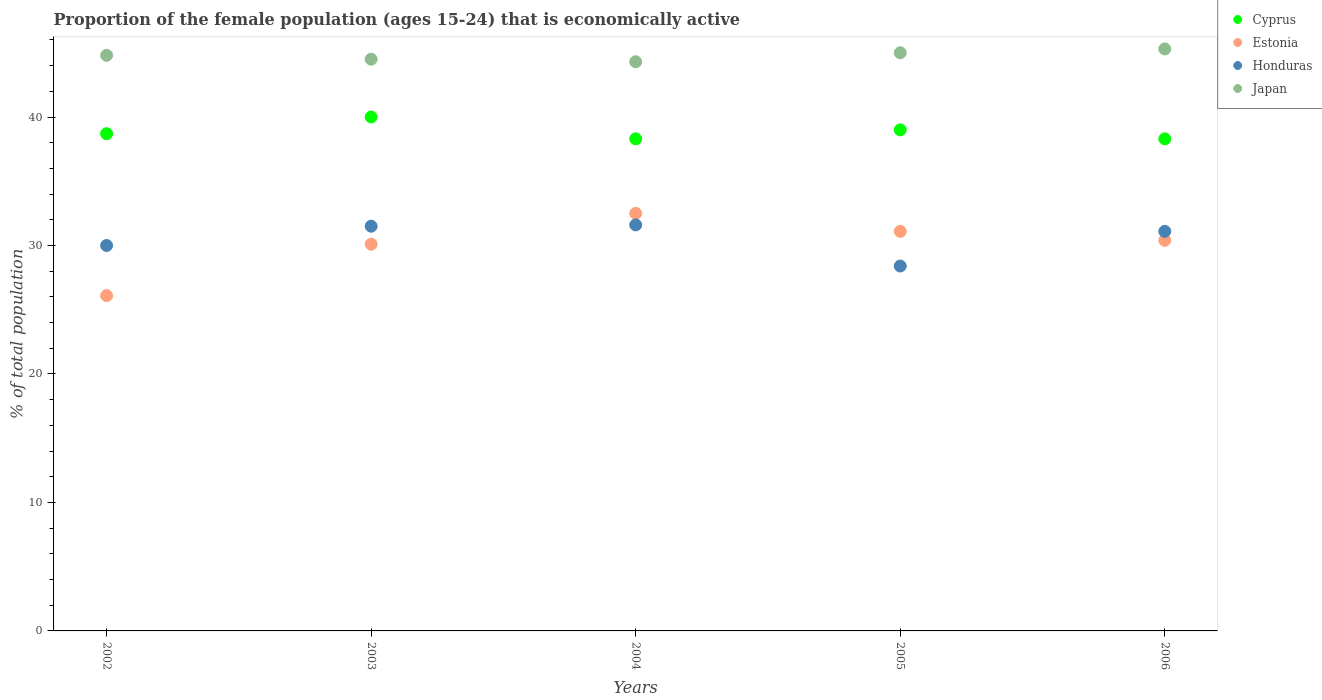How many different coloured dotlines are there?
Your answer should be compact. 4. What is the proportion of the female population that is economically active in Japan in 2004?
Offer a very short reply. 44.3. Across all years, what is the maximum proportion of the female population that is economically active in Cyprus?
Give a very brief answer. 40. Across all years, what is the minimum proportion of the female population that is economically active in Japan?
Provide a succinct answer. 44.3. What is the total proportion of the female population that is economically active in Japan in the graph?
Provide a succinct answer. 223.9. What is the difference between the proportion of the female population that is economically active in Honduras in 2003 and that in 2006?
Your answer should be very brief. 0.4. What is the difference between the proportion of the female population that is economically active in Cyprus in 2006 and the proportion of the female population that is economically active in Estonia in 2005?
Provide a short and direct response. 7.2. What is the average proportion of the female population that is economically active in Japan per year?
Give a very brief answer. 44.78. In the year 2005, what is the difference between the proportion of the female population that is economically active in Japan and proportion of the female population that is economically active in Cyprus?
Your answer should be very brief. 6. In how many years, is the proportion of the female population that is economically active in Honduras greater than 36 %?
Make the answer very short. 0. What is the ratio of the proportion of the female population that is economically active in Cyprus in 2002 to that in 2004?
Ensure brevity in your answer.  1.01. Is the difference between the proportion of the female population that is economically active in Japan in 2003 and 2006 greater than the difference between the proportion of the female population that is economically active in Cyprus in 2003 and 2006?
Provide a succinct answer. No. What is the difference between the highest and the second highest proportion of the female population that is economically active in Honduras?
Your answer should be compact. 0.1. What is the difference between the highest and the lowest proportion of the female population that is economically active in Cyprus?
Provide a succinct answer. 1.7. In how many years, is the proportion of the female population that is economically active in Japan greater than the average proportion of the female population that is economically active in Japan taken over all years?
Give a very brief answer. 3. How many dotlines are there?
Offer a terse response. 4. Are the values on the major ticks of Y-axis written in scientific E-notation?
Keep it short and to the point. No. Does the graph contain grids?
Offer a very short reply. No. What is the title of the graph?
Ensure brevity in your answer.  Proportion of the female population (ages 15-24) that is economically active. What is the label or title of the X-axis?
Your response must be concise. Years. What is the label or title of the Y-axis?
Provide a short and direct response. % of total population. What is the % of total population of Cyprus in 2002?
Ensure brevity in your answer.  38.7. What is the % of total population in Estonia in 2002?
Ensure brevity in your answer.  26.1. What is the % of total population of Japan in 2002?
Your answer should be very brief. 44.8. What is the % of total population in Estonia in 2003?
Provide a short and direct response. 30.1. What is the % of total population of Honduras in 2003?
Provide a succinct answer. 31.5. What is the % of total population of Japan in 2003?
Provide a succinct answer. 44.5. What is the % of total population in Cyprus in 2004?
Keep it short and to the point. 38.3. What is the % of total population of Estonia in 2004?
Your response must be concise. 32.5. What is the % of total population of Honduras in 2004?
Keep it short and to the point. 31.6. What is the % of total population in Japan in 2004?
Make the answer very short. 44.3. What is the % of total population in Cyprus in 2005?
Provide a succinct answer. 39. What is the % of total population in Estonia in 2005?
Your answer should be compact. 31.1. What is the % of total population in Honduras in 2005?
Provide a succinct answer. 28.4. What is the % of total population of Cyprus in 2006?
Ensure brevity in your answer.  38.3. What is the % of total population of Estonia in 2006?
Offer a terse response. 30.4. What is the % of total population in Honduras in 2006?
Your answer should be compact. 31.1. What is the % of total population of Japan in 2006?
Your answer should be compact. 45.3. Across all years, what is the maximum % of total population in Cyprus?
Offer a terse response. 40. Across all years, what is the maximum % of total population in Estonia?
Your answer should be very brief. 32.5. Across all years, what is the maximum % of total population in Honduras?
Your answer should be compact. 31.6. Across all years, what is the maximum % of total population in Japan?
Your answer should be very brief. 45.3. Across all years, what is the minimum % of total population in Cyprus?
Offer a very short reply. 38.3. Across all years, what is the minimum % of total population of Estonia?
Provide a succinct answer. 26.1. Across all years, what is the minimum % of total population of Honduras?
Provide a short and direct response. 28.4. Across all years, what is the minimum % of total population in Japan?
Ensure brevity in your answer.  44.3. What is the total % of total population in Cyprus in the graph?
Ensure brevity in your answer.  194.3. What is the total % of total population of Estonia in the graph?
Keep it short and to the point. 150.2. What is the total % of total population in Honduras in the graph?
Ensure brevity in your answer.  152.6. What is the total % of total population of Japan in the graph?
Give a very brief answer. 223.9. What is the difference between the % of total population in Cyprus in 2002 and that in 2003?
Offer a terse response. -1.3. What is the difference between the % of total population of Japan in 2002 and that in 2003?
Make the answer very short. 0.3. What is the difference between the % of total population in Cyprus in 2002 and that in 2004?
Ensure brevity in your answer.  0.4. What is the difference between the % of total population of Estonia in 2002 and that in 2004?
Your answer should be compact. -6.4. What is the difference between the % of total population of Japan in 2002 and that in 2004?
Your response must be concise. 0.5. What is the difference between the % of total population of Estonia in 2002 and that in 2005?
Give a very brief answer. -5. What is the difference between the % of total population in Japan in 2002 and that in 2005?
Your answer should be compact. -0.2. What is the difference between the % of total population in Cyprus in 2002 and that in 2006?
Offer a very short reply. 0.4. What is the difference between the % of total population of Cyprus in 2003 and that in 2004?
Provide a short and direct response. 1.7. What is the difference between the % of total population in Honduras in 2003 and that in 2004?
Keep it short and to the point. -0.1. What is the difference between the % of total population of Japan in 2003 and that in 2004?
Your answer should be compact. 0.2. What is the difference between the % of total population in Japan in 2003 and that in 2005?
Ensure brevity in your answer.  -0.5. What is the difference between the % of total population in Cyprus in 2003 and that in 2006?
Offer a terse response. 1.7. What is the difference between the % of total population in Estonia in 2003 and that in 2006?
Provide a short and direct response. -0.3. What is the difference between the % of total population of Estonia in 2004 and that in 2005?
Offer a terse response. 1.4. What is the difference between the % of total population of Japan in 2004 and that in 2005?
Keep it short and to the point. -0.7. What is the difference between the % of total population in Cyprus in 2004 and that in 2006?
Offer a very short reply. 0. What is the difference between the % of total population in Estonia in 2004 and that in 2006?
Offer a terse response. 2.1. What is the difference between the % of total population of Honduras in 2004 and that in 2006?
Your response must be concise. 0.5. What is the difference between the % of total population in Cyprus in 2005 and that in 2006?
Your answer should be very brief. 0.7. What is the difference between the % of total population of Estonia in 2005 and that in 2006?
Ensure brevity in your answer.  0.7. What is the difference between the % of total population of Honduras in 2005 and that in 2006?
Make the answer very short. -2.7. What is the difference between the % of total population of Japan in 2005 and that in 2006?
Make the answer very short. -0.3. What is the difference between the % of total population of Estonia in 2002 and the % of total population of Honduras in 2003?
Your answer should be very brief. -5.4. What is the difference between the % of total population of Estonia in 2002 and the % of total population of Japan in 2003?
Offer a terse response. -18.4. What is the difference between the % of total population of Honduras in 2002 and the % of total population of Japan in 2003?
Your answer should be compact. -14.5. What is the difference between the % of total population in Cyprus in 2002 and the % of total population in Honduras in 2004?
Give a very brief answer. 7.1. What is the difference between the % of total population in Cyprus in 2002 and the % of total population in Japan in 2004?
Provide a short and direct response. -5.6. What is the difference between the % of total population of Estonia in 2002 and the % of total population of Honduras in 2004?
Your answer should be compact. -5.5. What is the difference between the % of total population in Estonia in 2002 and the % of total population in Japan in 2004?
Provide a succinct answer. -18.2. What is the difference between the % of total population of Honduras in 2002 and the % of total population of Japan in 2004?
Provide a short and direct response. -14.3. What is the difference between the % of total population in Cyprus in 2002 and the % of total population in Estonia in 2005?
Provide a short and direct response. 7.6. What is the difference between the % of total population in Estonia in 2002 and the % of total population in Japan in 2005?
Offer a very short reply. -18.9. What is the difference between the % of total population in Honduras in 2002 and the % of total population in Japan in 2005?
Give a very brief answer. -15. What is the difference between the % of total population in Cyprus in 2002 and the % of total population in Estonia in 2006?
Offer a terse response. 8.3. What is the difference between the % of total population in Cyprus in 2002 and the % of total population in Honduras in 2006?
Ensure brevity in your answer.  7.6. What is the difference between the % of total population in Cyprus in 2002 and the % of total population in Japan in 2006?
Keep it short and to the point. -6.6. What is the difference between the % of total population in Estonia in 2002 and the % of total population in Japan in 2006?
Provide a succinct answer. -19.2. What is the difference between the % of total population of Honduras in 2002 and the % of total population of Japan in 2006?
Ensure brevity in your answer.  -15.3. What is the difference between the % of total population in Cyprus in 2003 and the % of total population in Estonia in 2004?
Provide a short and direct response. 7.5. What is the difference between the % of total population of Cyprus in 2003 and the % of total population of Honduras in 2004?
Keep it short and to the point. 8.4. What is the difference between the % of total population of Estonia in 2003 and the % of total population of Honduras in 2004?
Provide a short and direct response. -1.5. What is the difference between the % of total population in Estonia in 2003 and the % of total population in Japan in 2004?
Offer a terse response. -14.2. What is the difference between the % of total population in Honduras in 2003 and the % of total population in Japan in 2004?
Provide a short and direct response. -12.8. What is the difference between the % of total population of Cyprus in 2003 and the % of total population of Estonia in 2005?
Make the answer very short. 8.9. What is the difference between the % of total population of Cyprus in 2003 and the % of total population of Japan in 2005?
Keep it short and to the point. -5. What is the difference between the % of total population of Estonia in 2003 and the % of total population of Honduras in 2005?
Offer a terse response. 1.7. What is the difference between the % of total population in Estonia in 2003 and the % of total population in Japan in 2005?
Offer a very short reply. -14.9. What is the difference between the % of total population in Cyprus in 2003 and the % of total population in Honduras in 2006?
Your answer should be compact. 8.9. What is the difference between the % of total population of Estonia in 2003 and the % of total population of Honduras in 2006?
Keep it short and to the point. -1. What is the difference between the % of total population in Estonia in 2003 and the % of total population in Japan in 2006?
Provide a succinct answer. -15.2. What is the difference between the % of total population in Honduras in 2003 and the % of total population in Japan in 2006?
Your answer should be compact. -13.8. What is the difference between the % of total population in Cyprus in 2004 and the % of total population in Estonia in 2005?
Your response must be concise. 7.2. What is the difference between the % of total population of Estonia in 2004 and the % of total population of Japan in 2005?
Your response must be concise. -12.5. What is the difference between the % of total population of Cyprus in 2004 and the % of total population of Honduras in 2006?
Offer a very short reply. 7.2. What is the difference between the % of total population in Estonia in 2004 and the % of total population in Honduras in 2006?
Your response must be concise. 1.4. What is the difference between the % of total population in Estonia in 2004 and the % of total population in Japan in 2006?
Keep it short and to the point. -12.8. What is the difference between the % of total population of Honduras in 2004 and the % of total population of Japan in 2006?
Your answer should be compact. -13.7. What is the difference between the % of total population in Honduras in 2005 and the % of total population in Japan in 2006?
Your answer should be compact. -16.9. What is the average % of total population of Cyprus per year?
Your answer should be very brief. 38.86. What is the average % of total population of Estonia per year?
Give a very brief answer. 30.04. What is the average % of total population of Honduras per year?
Keep it short and to the point. 30.52. What is the average % of total population of Japan per year?
Ensure brevity in your answer.  44.78. In the year 2002, what is the difference between the % of total population of Cyprus and % of total population of Honduras?
Keep it short and to the point. 8.7. In the year 2002, what is the difference between the % of total population of Estonia and % of total population of Honduras?
Your answer should be compact. -3.9. In the year 2002, what is the difference between the % of total population in Estonia and % of total population in Japan?
Provide a short and direct response. -18.7. In the year 2002, what is the difference between the % of total population of Honduras and % of total population of Japan?
Keep it short and to the point. -14.8. In the year 2003, what is the difference between the % of total population of Cyprus and % of total population of Honduras?
Your answer should be very brief. 8.5. In the year 2003, what is the difference between the % of total population of Estonia and % of total population of Japan?
Offer a terse response. -14.4. In the year 2004, what is the difference between the % of total population in Cyprus and % of total population in Estonia?
Provide a short and direct response. 5.8. In the year 2004, what is the difference between the % of total population of Cyprus and % of total population of Japan?
Give a very brief answer. -6. In the year 2004, what is the difference between the % of total population in Estonia and % of total population in Honduras?
Offer a terse response. 0.9. In the year 2004, what is the difference between the % of total population in Honduras and % of total population in Japan?
Provide a succinct answer. -12.7. In the year 2005, what is the difference between the % of total population of Cyprus and % of total population of Estonia?
Your response must be concise. 7.9. In the year 2005, what is the difference between the % of total population in Cyprus and % of total population in Honduras?
Provide a succinct answer. 10.6. In the year 2005, what is the difference between the % of total population in Cyprus and % of total population in Japan?
Offer a very short reply. -6. In the year 2005, what is the difference between the % of total population of Honduras and % of total population of Japan?
Offer a terse response. -16.6. In the year 2006, what is the difference between the % of total population in Estonia and % of total population in Japan?
Provide a short and direct response. -14.9. What is the ratio of the % of total population in Cyprus in 2002 to that in 2003?
Offer a terse response. 0.97. What is the ratio of the % of total population of Estonia in 2002 to that in 2003?
Provide a short and direct response. 0.87. What is the ratio of the % of total population in Japan in 2002 to that in 2003?
Provide a short and direct response. 1.01. What is the ratio of the % of total population of Cyprus in 2002 to that in 2004?
Ensure brevity in your answer.  1.01. What is the ratio of the % of total population in Estonia in 2002 to that in 2004?
Your answer should be compact. 0.8. What is the ratio of the % of total population in Honduras in 2002 to that in 2004?
Provide a short and direct response. 0.95. What is the ratio of the % of total population in Japan in 2002 to that in 2004?
Provide a short and direct response. 1.01. What is the ratio of the % of total population of Cyprus in 2002 to that in 2005?
Provide a short and direct response. 0.99. What is the ratio of the % of total population in Estonia in 2002 to that in 2005?
Offer a terse response. 0.84. What is the ratio of the % of total population of Honduras in 2002 to that in 2005?
Your answer should be very brief. 1.06. What is the ratio of the % of total population in Japan in 2002 to that in 2005?
Your response must be concise. 1. What is the ratio of the % of total population of Cyprus in 2002 to that in 2006?
Keep it short and to the point. 1.01. What is the ratio of the % of total population in Estonia in 2002 to that in 2006?
Make the answer very short. 0.86. What is the ratio of the % of total population in Honduras in 2002 to that in 2006?
Your answer should be very brief. 0.96. What is the ratio of the % of total population in Cyprus in 2003 to that in 2004?
Keep it short and to the point. 1.04. What is the ratio of the % of total population in Estonia in 2003 to that in 2004?
Provide a succinct answer. 0.93. What is the ratio of the % of total population of Honduras in 2003 to that in 2004?
Provide a short and direct response. 1. What is the ratio of the % of total population of Japan in 2003 to that in 2004?
Your response must be concise. 1. What is the ratio of the % of total population of Cyprus in 2003 to that in 2005?
Your answer should be very brief. 1.03. What is the ratio of the % of total population of Estonia in 2003 to that in 2005?
Provide a succinct answer. 0.97. What is the ratio of the % of total population in Honduras in 2003 to that in 2005?
Keep it short and to the point. 1.11. What is the ratio of the % of total population in Japan in 2003 to that in 2005?
Ensure brevity in your answer.  0.99. What is the ratio of the % of total population of Cyprus in 2003 to that in 2006?
Your response must be concise. 1.04. What is the ratio of the % of total population of Honduras in 2003 to that in 2006?
Offer a terse response. 1.01. What is the ratio of the % of total population in Japan in 2003 to that in 2006?
Offer a terse response. 0.98. What is the ratio of the % of total population in Cyprus in 2004 to that in 2005?
Offer a very short reply. 0.98. What is the ratio of the % of total population of Estonia in 2004 to that in 2005?
Provide a succinct answer. 1.04. What is the ratio of the % of total population in Honduras in 2004 to that in 2005?
Make the answer very short. 1.11. What is the ratio of the % of total population of Japan in 2004 to that in 2005?
Provide a succinct answer. 0.98. What is the ratio of the % of total population in Estonia in 2004 to that in 2006?
Your response must be concise. 1.07. What is the ratio of the % of total population in Honduras in 2004 to that in 2006?
Make the answer very short. 1.02. What is the ratio of the % of total population of Japan in 2004 to that in 2006?
Make the answer very short. 0.98. What is the ratio of the % of total population of Cyprus in 2005 to that in 2006?
Ensure brevity in your answer.  1.02. What is the ratio of the % of total population in Estonia in 2005 to that in 2006?
Make the answer very short. 1.02. What is the ratio of the % of total population of Honduras in 2005 to that in 2006?
Your response must be concise. 0.91. What is the ratio of the % of total population of Japan in 2005 to that in 2006?
Give a very brief answer. 0.99. What is the difference between the highest and the second highest % of total population in Cyprus?
Your response must be concise. 1. What is the difference between the highest and the second highest % of total population of Honduras?
Ensure brevity in your answer.  0.1. What is the difference between the highest and the second highest % of total population in Japan?
Give a very brief answer. 0.3. What is the difference between the highest and the lowest % of total population of Estonia?
Your answer should be very brief. 6.4. What is the difference between the highest and the lowest % of total population in Honduras?
Provide a succinct answer. 3.2. 